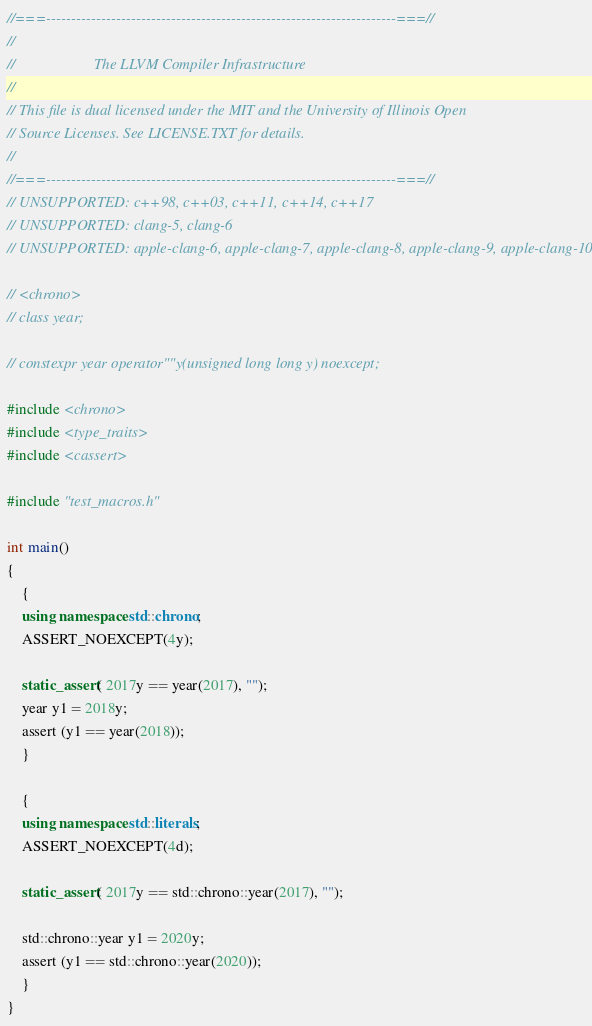<code> <loc_0><loc_0><loc_500><loc_500><_C++_>//===----------------------------------------------------------------------===//
//
//                     The LLVM Compiler Infrastructure
//
// This file is dual licensed under the MIT and the University of Illinois Open
// Source Licenses. See LICENSE.TXT for details.
//
//===----------------------------------------------------------------------===//
// UNSUPPORTED: c++98, c++03, c++11, c++14, c++17
// UNSUPPORTED: clang-5, clang-6
// UNSUPPORTED: apple-clang-6, apple-clang-7, apple-clang-8, apple-clang-9, apple-clang-10

// <chrono>
// class year;

// constexpr year operator""y(unsigned long long y) noexcept;

#include <chrono>
#include <type_traits>
#include <cassert>

#include "test_macros.h"

int main()
{
    {
    using namespace std::chrono;
    ASSERT_NOEXCEPT(4y);

    static_assert( 2017y == year(2017), "");
    year y1 = 2018y;
    assert (y1 == year(2018));
    }

    {
    using namespace std::literals;
    ASSERT_NOEXCEPT(4d);

    static_assert( 2017y == std::chrono::year(2017), "");

    std::chrono::year y1 = 2020y;
    assert (y1 == std::chrono::year(2020));
    }
}
</code> 